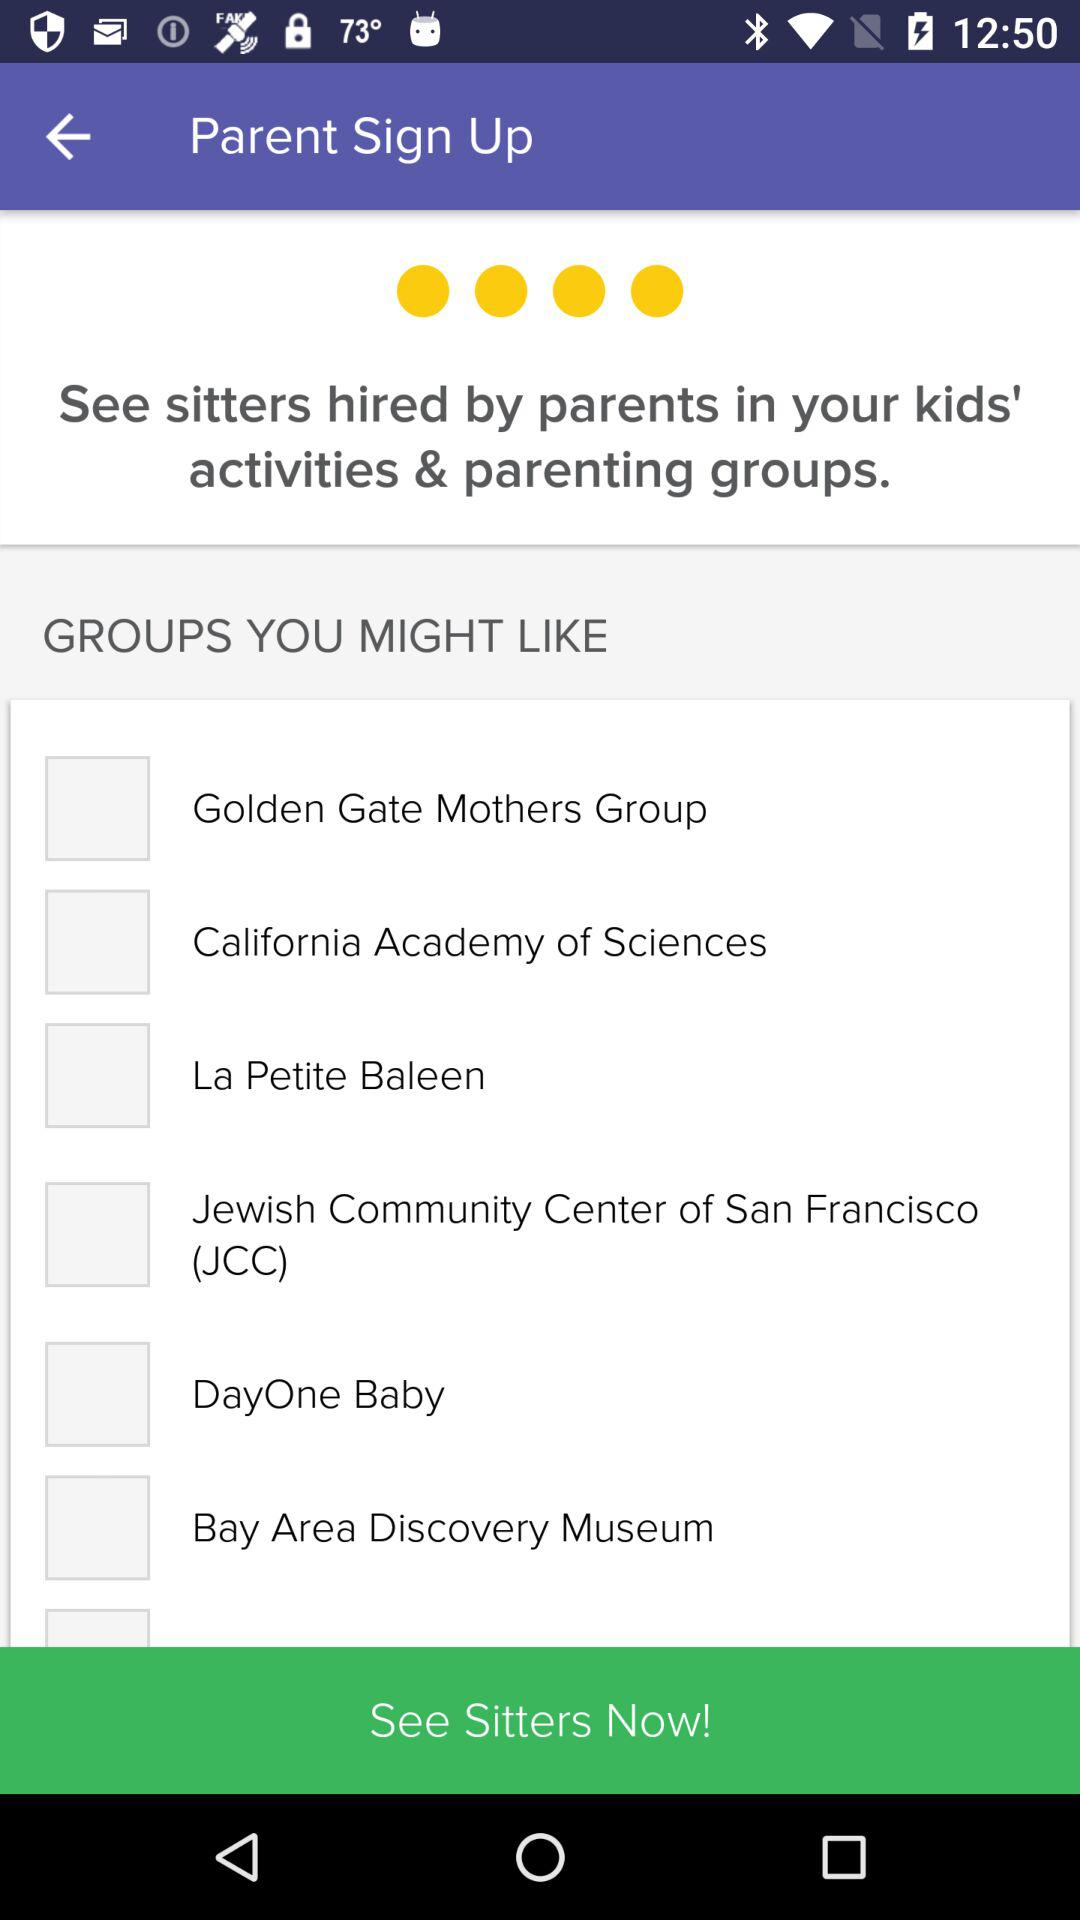How many kids does the user have?
When the provided information is insufficient, respond with <no answer>. <no answer> 